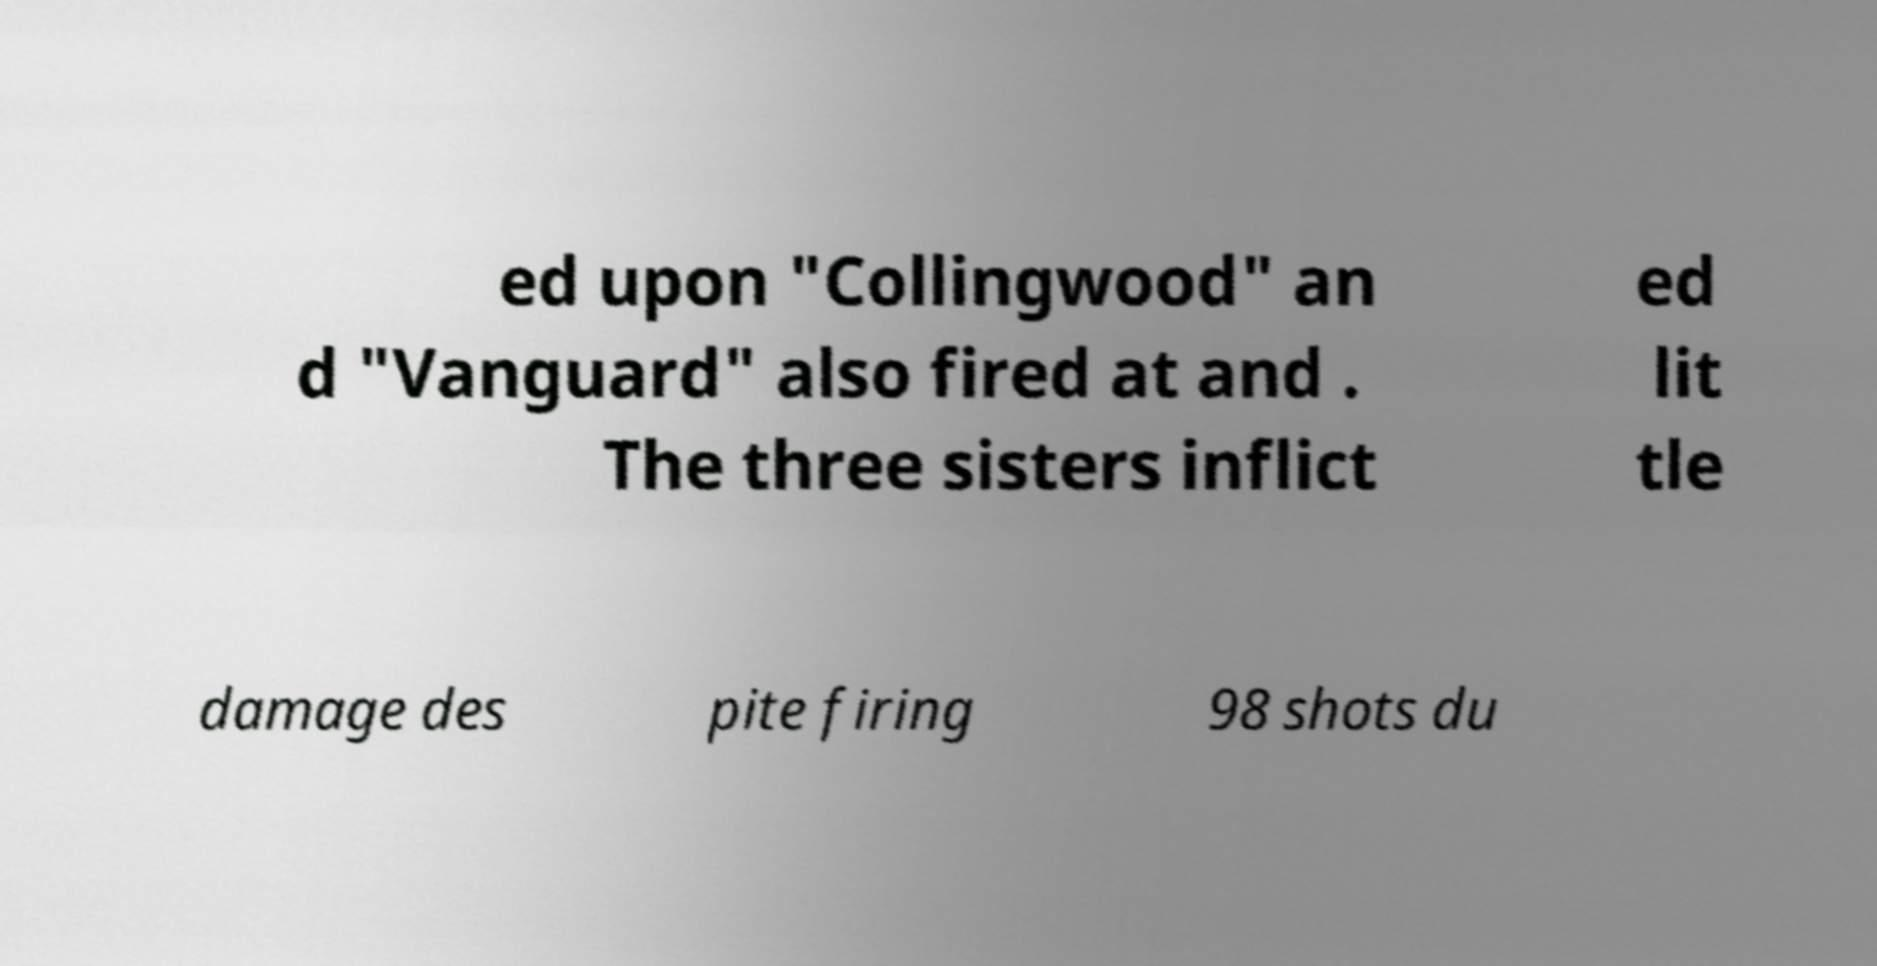There's text embedded in this image that I need extracted. Can you transcribe it verbatim? ed upon "Collingwood" an d "Vanguard" also fired at and . The three sisters inflict ed lit tle damage des pite firing 98 shots du 